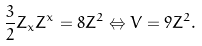Convert formula to latex. <formula><loc_0><loc_0><loc_500><loc_500>\frac { 3 } { 2 } Z _ { x } Z ^ { x } = 8 Z ^ { 2 } \Leftrightarrow V = 9 Z ^ { 2 } .</formula> 